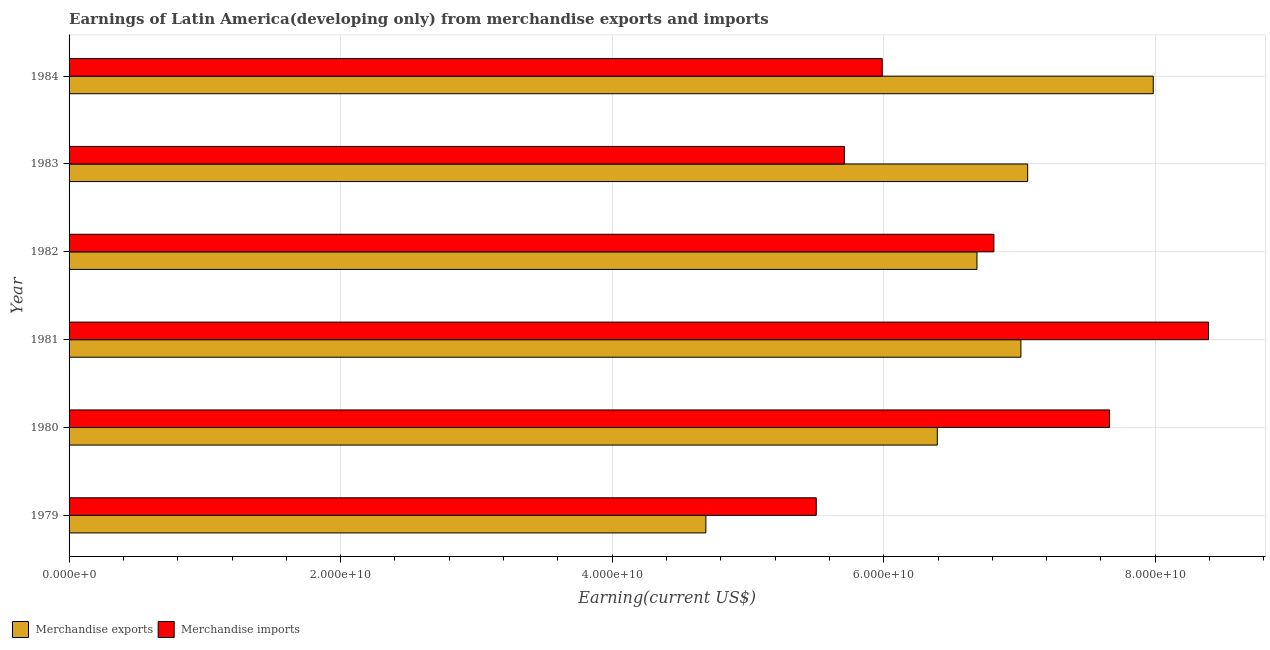How many different coloured bars are there?
Provide a short and direct response. 2. Are the number of bars on each tick of the Y-axis equal?
Offer a terse response. Yes. How many bars are there on the 5th tick from the bottom?
Your response must be concise. 2. What is the label of the 2nd group of bars from the top?
Offer a terse response. 1983. What is the earnings from merchandise exports in 1982?
Your response must be concise. 6.69e+1. Across all years, what is the maximum earnings from merchandise exports?
Your response must be concise. 7.99e+1. Across all years, what is the minimum earnings from merchandise imports?
Offer a terse response. 5.50e+1. In which year was the earnings from merchandise exports minimum?
Provide a succinct answer. 1979. What is the total earnings from merchandise exports in the graph?
Offer a terse response. 3.98e+11. What is the difference between the earnings from merchandise exports in 1979 and that in 1982?
Your response must be concise. -2.00e+1. What is the difference between the earnings from merchandise imports in 1981 and the earnings from merchandise exports in 1980?
Ensure brevity in your answer.  2.00e+1. What is the average earnings from merchandise imports per year?
Make the answer very short. 6.68e+1. In the year 1979, what is the difference between the earnings from merchandise exports and earnings from merchandise imports?
Your answer should be compact. -8.13e+09. What is the ratio of the earnings from merchandise exports in 1980 to that in 1984?
Ensure brevity in your answer.  0.8. What is the difference between the highest and the second highest earnings from merchandise imports?
Make the answer very short. 7.29e+09. What is the difference between the highest and the lowest earnings from merchandise imports?
Offer a terse response. 2.89e+1. What does the 2nd bar from the top in 1979 represents?
Offer a terse response. Merchandise exports. How many years are there in the graph?
Make the answer very short. 6. Are the values on the major ticks of X-axis written in scientific E-notation?
Keep it short and to the point. Yes. Does the graph contain any zero values?
Your answer should be very brief. No. Where does the legend appear in the graph?
Give a very brief answer. Bottom left. What is the title of the graph?
Keep it short and to the point. Earnings of Latin America(developing only) from merchandise exports and imports. What is the label or title of the X-axis?
Offer a terse response. Earning(current US$). What is the Earning(current US$) in Merchandise exports in 1979?
Your response must be concise. 4.69e+1. What is the Earning(current US$) in Merchandise imports in 1979?
Provide a succinct answer. 5.50e+1. What is the Earning(current US$) in Merchandise exports in 1980?
Keep it short and to the point. 6.40e+1. What is the Earning(current US$) in Merchandise imports in 1980?
Offer a terse response. 7.66e+1. What is the Earning(current US$) of Merchandise exports in 1981?
Your answer should be very brief. 7.01e+1. What is the Earning(current US$) in Merchandise imports in 1981?
Your answer should be very brief. 8.39e+1. What is the Earning(current US$) in Merchandise exports in 1982?
Provide a short and direct response. 6.69e+1. What is the Earning(current US$) of Merchandise imports in 1982?
Provide a short and direct response. 6.81e+1. What is the Earning(current US$) of Merchandise exports in 1983?
Make the answer very short. 7.06e+1. What is the Earning(current US$) in Merchandise imports in 1983?
Your answer should be compact. 5.71e+1. What is the Earning(current US$) of Merchandise exports in 1984?
Provide a short and direct response. 7.99e+1. What is the Earning(current US$) in Merchandise imports in 1984?
Your answer should be compact. 5.99e+1. Across all years, what is the maximum Earning(current US$) of Merchandise exports?
Offer a very short reply. 7.99e+1. Across all years, what is the maximum Earning(current US$) of Merchandise imports?
Provide a short and direct response. 8.39e+1. Across all years, what is the minimum Earning(current US$) of Merchandise exports?
Your answer should be very brief. 4.69e+1. Across all years, what is the minimum Earning(current US$) in Merchandise imports?
Your answer should be compact. 5.50e+1. What is the total Earning(current US$) in Merchandise exports in the graph?
Your response must be concise. 3.98e+11. What is the total Earning(current US$) in Merchandise imports in the graph?
Provide a short and direct response. 4.01e+11. What is the difference between the Earning(current US$) of Merchandise exports in 1979 and that in 1980?
Ensure brevity in your answer.  -1.70e+1. What is the difference between the Earning(current US$) of Merchandise imports in 1979 and that in 1980?
Make the answer very short. -2.16e+1. What is the difference between the Earning(current US$) in Merchandise exports in 1979 and that in 1981?
Give a very brief answer. -2.32e+1. What is the difference between the Earning(current US$) of Merchandise imports in 1979 and that in 1981?
Ensure brevity in your answer.  -2.89e+1. What is the difference between the Earning(current US$) of Merchandise exports in 1979 and that in 1982?
Ensure brevity in your answer.  -2.00e+1. What is the difference between the Earning(current US$) in Merchandise imports in 1979 and that in 1982?
Provide a short and direct response. -1.31e+1. What is the difference between the Earning(current US$) in Merchandise exports in 1979 and that in 1983?
Keep it short and to the point. -2.37e+1. What is the difference between the Earning(current US$) of Merchandise imports in 1979 and that in 1983?
Your response must be concise. -2.07e+09. What is the difference between the Earning(current US$) in Merchandise exports in 1979 and that in 1984?
Provide a short and direct response. -3.30e+1. What is the difference between the Earning(current US$) of Merchandise imports in 1979 and that in 1984?
Your response must be concise. -4.86e+09. What is the difference between the Earning(current US$) of Merchandise exports in 1980 and that in 1981?
Ensure brevity in your answer.  -6.16e+09. What is the difference between the Earning(current US$) of Merchandise imports in 1980 and that in 1981?
Give a very brief answer. -7.29e+09. What is the difference between the Earning(current US$) in Merchandise exports in 1980 and that in 1982?
Your response must be concise. -2.92e+09. What is the difference between the Earning(current US$) in Merchandise imports in 1980 and that in 1982?
Offer a terse response. 8.52e+09. What is the difference between the Earning(current US$) of Merchandise exports in 1980 and that in 1983?
Offer a very short reply. -6.65e+09. What is the difference between the Earning(current US$) in Merchandise imports in 1980 and that in 1983?
Provide a short and direct response. 1.95e+1. What is the difference between the Earning(current US$) of Merchandise exports in 1980 and that in 1984?
Provide a short and direct response. -1.59e+1. What is the difference between the Earning(current US$) of Merchandise imports in 1980 and that in 1984?
Your answer should be compact. 1.67e+1. What is the difference between the Earning(current US$) in Merchandise exports in 1981 and that in 1982?
Ensure brevity in your answer.  3.24e+09. What is the difference between the Earning(current US$) in Merchandise imports in 1981 and that in 1982?
Your answer should be very brief. 1.58e+1. What is the difference between the Earning(current US$) in Merchandise exports in 1981 and that in 1983?
Offer a very short reply. -4.98e+08. What is the difference between the Earning(current US$) in Merchandise imports in 1981 and that in 1983?
Offer a very short reply. 2.68e+1. What is the difference between the Earning(current US$) in Merchandise exports in 1981 and that in 1984?
Provide a succinct answer. -9.75e+09. What is the difference between the Earning(current US$) of Merchandise imports in 1981 and that in 1984?
Your answer should be very brief. 2.40e+1. What is the difference between the Earning(current US$) in Merchandise exports in 1982 and that in 1983?
Give a very brief answer. -3.73e+09. What is the difference between the Earning(current US$) in Merchandise imports in 1982 and that in 1983?
Offer a very short reply. 1.10e+1. What is the difference between the Earning(current US$) in Merchandise exports in 1982 and that in 1984?
Your answer should be compact. -1.30e+1. What is the difference between the Earning(current US$) of Merchandise imports in 1982 and that in 1984?
Provide a short and direct response. 8.22e+09. What is the difference between the Earning(current US$) in Merchandise exports in 1983 and that in 1984?
Your response must be concise. -9.25e+09. What is the difference between the Earning(current US$) in Merchandise imports in 1983 and that in 1984?
Make the answer very short. -2.78e+09. What is the difference between the Earning(current US$) in Merchandise exports in 1979 and the Earning(current US$) in Merchandise imports in 1980?
Make the answer very short. -2.97e+1. What is the difference between the Earning(current US$) of Merchandise exports in 1979 and the Earning(current US$) of Merchandise imports in 1981?
Make the answer very short. -3.70e+1. What is the difference between the Earning(current US$) in Merchandise exports in 1979 and the Earning(current US$) in Merchandise imports in 1982?
Offer a very short reply. -2.12e+1. What is the difference between the Earning(current US$) in Merchandise exports in 1979 and the Earning(current US$) in Merchandise imports in 1983?
Give a very brief answer. -1.02e+1. What is the difference between the Earning(current US$) of Merchandise exports in 1979 and the Earning(current US$) of Merchandise imports in 1984?
Provide a short and direct response. -1.30e+1. What is the difference between the Earning(current US$) in Merchandise exports in 1980 and the Earning(current US$) in Merchandise imports in 1981?
Make the answer very short. -2.00e+1. What is the difference between the Earning(current US$) of Merchandise exports in 1980 and the Earning(current US$) of Merchandise imports in 1982?
Give a very brief answer. -4.17e+09. What is the difference between the Earning(current US$) in Merchandise exports in 1980 and the Earning(current US$) in Merchandise imports in 1983?
Your answer should be very brief. 6.84e+09. What is the difference between the Earning(current US$) of Merchandise exports in 1980 and the Earning(current US$) of Merchandise imports in 1984?
Keep it short and to the point. 4.06e+09. What is the difference between the Earning(current US$) in Merchandise exports in 1981 and the Earning(current US$) in Merchandise imports in 1982?
Offer a very short reply. 1.99e+09. What is the difference between the Earning(current US$) of Merchandise exports in 1981 and the Earning(current US$) of Merchandise imports in 1983?
Keep it short and to the point. 1.30e+1. What is the difference between the Earning(current US$) in Merchandise exports in 1981 and the Earning(current US$) in Merchandise imports in 1984?
Your response must be concise. 1.02e+1. What is the difference between the Earning(current US$) of Merchandise exports in 1982 and the Earning(current US$) of Merchandise imports in 1983?
Provide a succinct answer. 9.76e+09. What is the difference between the Earning(current US$) of Merchandise exports in 1982 and the Earning(current US$) of Merchandise imports in 1984?
Provide a short and direct response. 6.98e+09. What is the difference between the Earning(current US$) in Merchandise exports in 1983 and the Earning(current US$) in Merchandise imports in 1984?
Give a very brief answer. 1.07e+1. What is the average Earning(current US$) of Merchandise exports per year?
Give a very brief answer. 6.64e+1. What is the average Earning(current US$) of Merchandise imports per year?
Your answer should be very brief. 6.68e+1. In the year 1979, what is the difference between the Earning(current US$) of Merchandise exports and Earning(current US$) of Merchandise imports?
Your response must be concise. -8.13e+09. In the year 1980, what is the difference between the Earning(current US$) in Merchandise exports and Earning(current US$) in Merchandise imports?
Make the answer very short. -1.27e+1. In the year 1981, what is the difference between the Earning(current US$) of Merchandise exports and Earning(current US$) of Merchandise imports?
Your response must be concise. -1.38e+1. In the year 1982, what is the difference between the Earning(current US$) in Merchandise exports and Earning(current US$) in Merchandise imports?
Keep it short and to the point. -1.25e+09. In the year 1983, what is the difference between the Earning(current US$) in Merchandise exports and Earning(current US$) in Merchandise imports?
Give a very brief answer. 1.35e+1. In the year 1984, what is the difference between the Earning(current US$) in Merchandise exports and Earning(current US$) in Merchandise imports?
Ensure brevity in your answer.  2.00e+1. What is the ratio of the Earning(current US$) of Merchandise exports in 1979 to that in 1980?
Give a very brief answer. 0.73. What is the ratio of the Earning(current US$) in Merchandise imports in 1979 to that in 1980?
Provide a short and direct response. 0.72. What is the ratio of the Earning(current US$) of Merchandise exports in 1979 to that in 1981?
Give a very brief answer. 0.67. What is the ratio of the Earning(current US$) of Merchandise imports in 1979 to that in 1981?
Ensure brevity in your answer.  0.66. What is the ratio of the Earning(current US$) of Merchandise exports in 1979 to that in 1982?
Provide a succinct answer. 0.7. What is the ratio of the Earning(current US$) in Merchandise imports in 1979 to that in 1982?
Make the answer very short. 0.81. What is the ratio of the Earning(current US$) in Merchandise exports in 1979 to that in 1983?
Keep it short and to the point. 0.66. What is the ratio of the Earning(current US$) in Merchandise imports in 1979 to that in 1983?
Offer a very short reply. 0.96. What is the ratio of the Earning(current US$) in Merchandise exports in 1979 to that in 1984?
Make the answer very short. 0.59. What is the ratio of the Earning(current US$) in Merchandise imports in 1979 to that in 1984?
Your response must be concise. 0.92. What is the ratio of the Earning(current US$) in Merchandise exports in 1980 to that in 1981?
Offer a terse response. 0.91. What is the ratio of the Earning(current US$) of Merchandise imports in 1980 to that in 1981?
Provide a succinct answer. 0.91. What is the ratio of the Earning(current US$) in Merchandise exports in 1980 to that in 1982?
Your response must be concise. 0.96. What is the ratio of the Earning(current US$) in Merchandise imports in 1980 to that in 1982?
Make the answer very short. 1.13. What is the ratio of the Earning(current US$) of Merchandise exports in 1980 to that in 1983?
Keep it short and to the point. 0.91. What is the ratio of the Earning(current US$) in Merchandise imports in 1980 to that in 1983?
Provide a short and direct response. 1.34. What is the ratio of the Earning(current US$) of Merchandise exports in 1980 to that in 1984?
Keep it short and to the point. 0.8. What is the ratio of the Earning(current US$) of Merchandise imports in 1980 to that in 1984?
Provide a short and direct response. 1.28. What is the ratio of the Earning(current US$) in Merchandise exports in 1981 to that in 1982?
Offer a terse response. 1.05. What is the ratio of the Earning(current US$) of Merchandise imports in 1981 to that in 1982?
Make the answer very short. 1.23. What is the ratio of the Earning(current US$) of Merchandise exports in 1981 to that in 1983?
Make the answer very short. 0.99. What is the ratio of the Earning(current US$) of Merchandise imports in 1981 to that in 1983?
Provide a succinct answer. 1.47. What is the ratio of the Earning(current US$) of Merchandise exports in 1981 to that in 1984?
Offer a very short reply. 0.88. What is the ratio of the Earning(current US$) of Merchandise imports in 1981 to that in 1984?
Keep it short and to the point. 1.4. What is the ratio of the Earning(current US$) of Merchandise exports in 1982 to that in 1983?
Give a very brief answer. 0.95. What is the ratio of the Earning(current US$) in Merchandise imports in 1982 to that in 1983?
Your response must be concise. 1.19. What is the ratio of the Earning(current US$) of Merchandise exports in 1982 to that in 1984?
Provide a short and direct response. 0.84. What is the ratio of the Earning(current US$) in Merchandise imports in 1982 to that in 1984?
Your response must be concise. 1.14. What is the ratio of the Earning(current US$) in Merchandise exports in 1983 to that in 1984?
Keep it short and to the point. 0.88. What is the ratio of the Earning(current US$) of Merchandise imports in 1983 to that in 1984?
Keep it short and to the point. 0.95. What is the difference between the highest and the second highest Earning(current US$) in Merchandise exports?
Your answer should be very brief. 9.25e+09. What is the difference between the highest and the second highest Earning(current US$) of Merchandise imports?
Your answer should be compact. 7.29e+09. What is the difference between the highest and the lowest Earning(current US$) of Merchandise exports?
Offer a very short reply. 3.30e+1. What is the difference between the highest and the lowest Earning(current US$) in Merchandise imports?
Make the answer very short. 2.89e+1. 